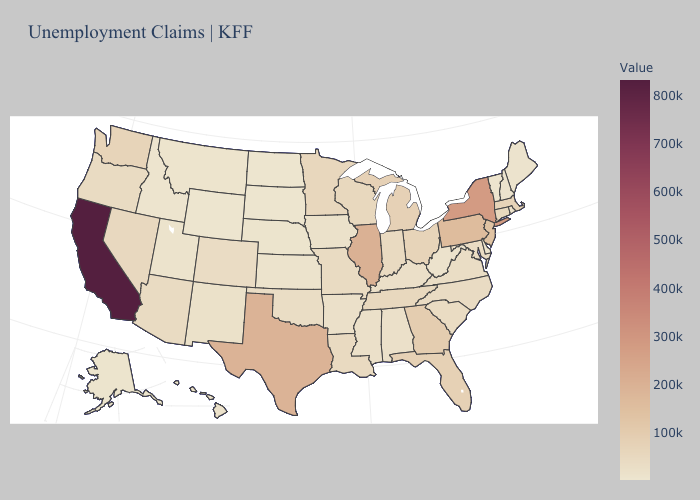Does the map have missing data?
Be succinct. No. Does Utah have a higher value than Pennsylvania?
Quick response, please. No. Which states have the lowest value in the USA?
Be succinct. South Dakota. Does New York have the highest value in the Northeast?
Keep it brief. Yes. Among the states that border Texas , does Louisiana have the highest value?
Give a very brief answer. Yes. 